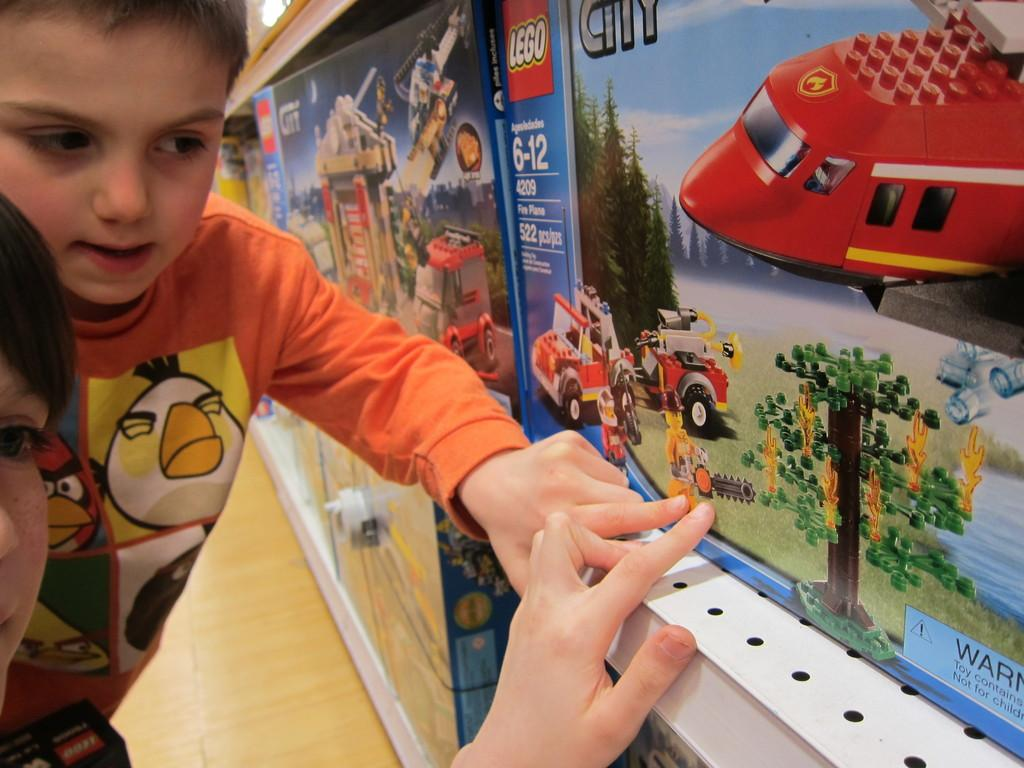<image>
Describe the image concisely. A Lego set is designed for ages 6 through 12. 